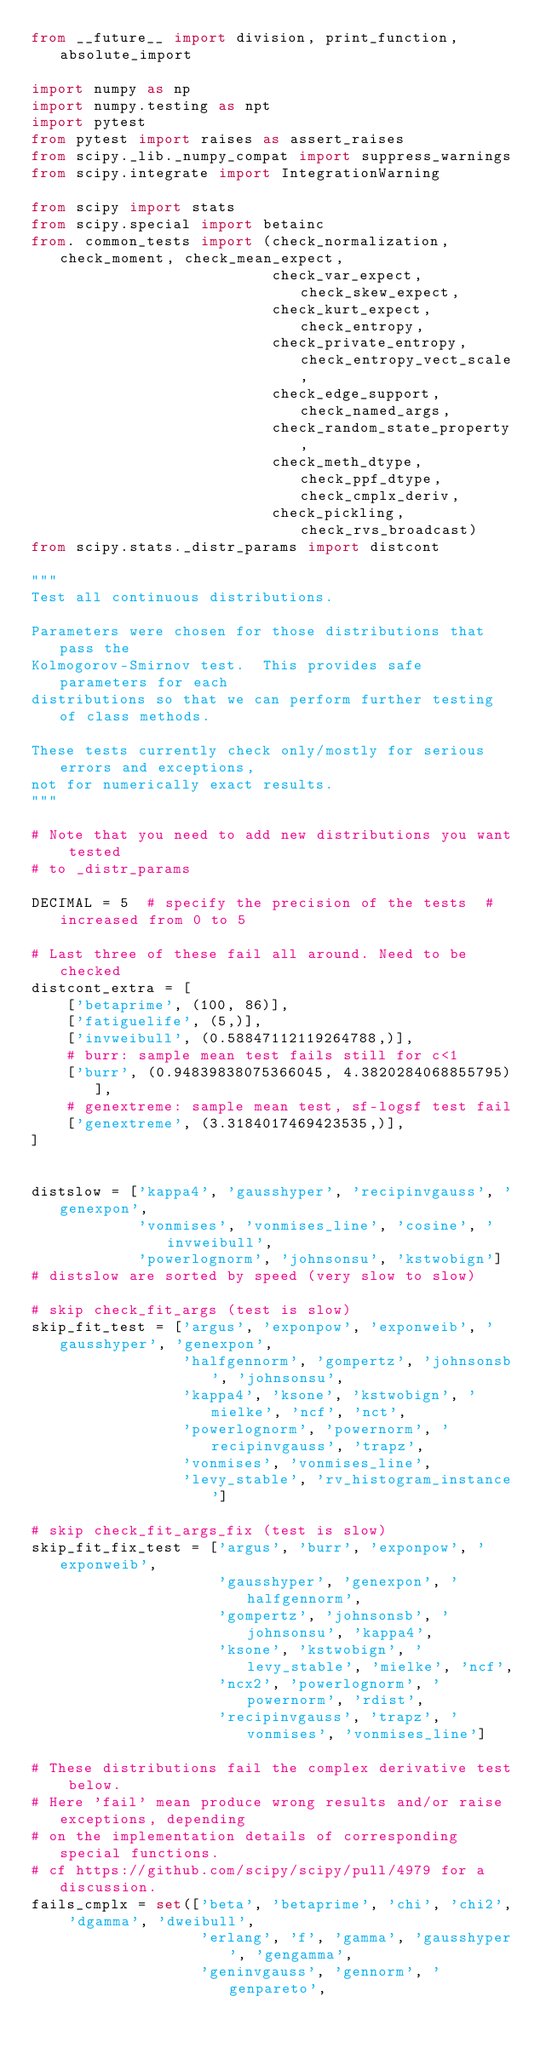<code> <loc_0><loc_0><loc_500><loc_500><_Python_>from __future__ import division, print_function, absolute_import

import numpy as np
import numpy.testing as npt
import pytest
from pytest import raises as assert_raises
from scipy._lib._numpy_compat import suppress_warnings
from scipy.integrate import IntegrationWarning

from scipy import stats
from scipy.special import betainc
from. common_tests import (check_normalization, check_moment, check_mean_expect,
                           check_var_expect, check_skew_expect,
                           check_kurt_expect, check_entropy,
                           check_private_entropy, check_entropy_vect_scale,
                           check_edge_support, check_named_args,
                           check_random_state_property,
                           check_meth_dtype, check_ppf_dtype, check_cmplx_deriv,
                           check_pickling, check_rvs_broadcast)
from scipy.stats._distr_params import distcont

"""
Test all continuous distributions.

Parameters were chosen for those distributions that pass the
Kolmogorov-Smirnov test.  This provides safe parameters for each
distributions so that we can perform further testing of class methods.

These tests currently check only/mostly for serious errors and exceptions,
not for numerically exact results.
"""

# Note that you need to add new distributions you want tested
# to _distr_params

DECIMAL = 5  # specify the precision of the tests  # increased from 0 to 5

# Last three of these fail all around. Need to be checked
distcont_extra = [
    ['betaprime', (100, 86)],
    ['fatiguelife', (5,)],
    ['invweibull', (0.58847112119264788,)],
    # burr: sample mean test fails still for c<1
    ['burr', (0.94839838075366045, 4.3820284068855795)],
    # genextreme: sample mean test, sf-logsf test fail
    ['genextreme', (3.3184017469423535,)],
]


distslow = ['kappa4', 'gausshyper', 'recipinvgauss', 'genexpon',
            'vonmises', 'vonmises_line', 'cosine', 'invweibull',
            'powerlognorm', 'johnsonsu', 'kstwobign']
# distslow are sorted by speed (very slow to slow)

# skip check_fit_args (test is slow)
skip_fit_test = ['argus', 'exponpow', 'exponweib', 'gausshyper', 'genexpon',
                 'halfgennorm', 'gompertz', 'johnsonsb', 'johnsonsu',
                 'kappa4', 'ksone', 'kstwobign', 'mielke', 'ncf', 'nct',
                 'powerlognorm', 'powernorm', 'recipinvgauss', 'trapz',
                 'vonmises', 'vonmises_line',
                 'levy_stable', 'rv_histogram_instance']

# skip check_fit_args_fix (test is slow)
skip_fit_fix_test = ['argus', 'burr', 'exponpow', 'exponweib',
                     'gausshyper', 'genexpon', 'halfgennorm',
                     'gompertz', 'johnsonsb', 'johnsonsu', 'kappa4',
                     'ksone', 'kstwobign', 'levy_stable', 'mielke', 'ncf',
                     'ncx2', 'powerlognorm', 'powernorm', 'rdist',
                     'recipinvgauss', 'trapz', 'vonmises', 'vonmises_line']

# These distributions fail the complex derivative test below.
# Here 'fail' mean produce wrong results and/or raise exceptions, depending
# on the implementation details of corresponding special functions.
# cf https://github.com/scipy/scipy/pull/4979 for a discussion.
fails_cmplx = set(['beta', 'betaprime', 'chi', 'chi2', 'dgamma', 'dweibull',
                   'erlang', 'f', 'gamma', 'gausshyper', 'gengamma',
                   'geninvgauss', 'gennorm', 'genpareto',</code> 